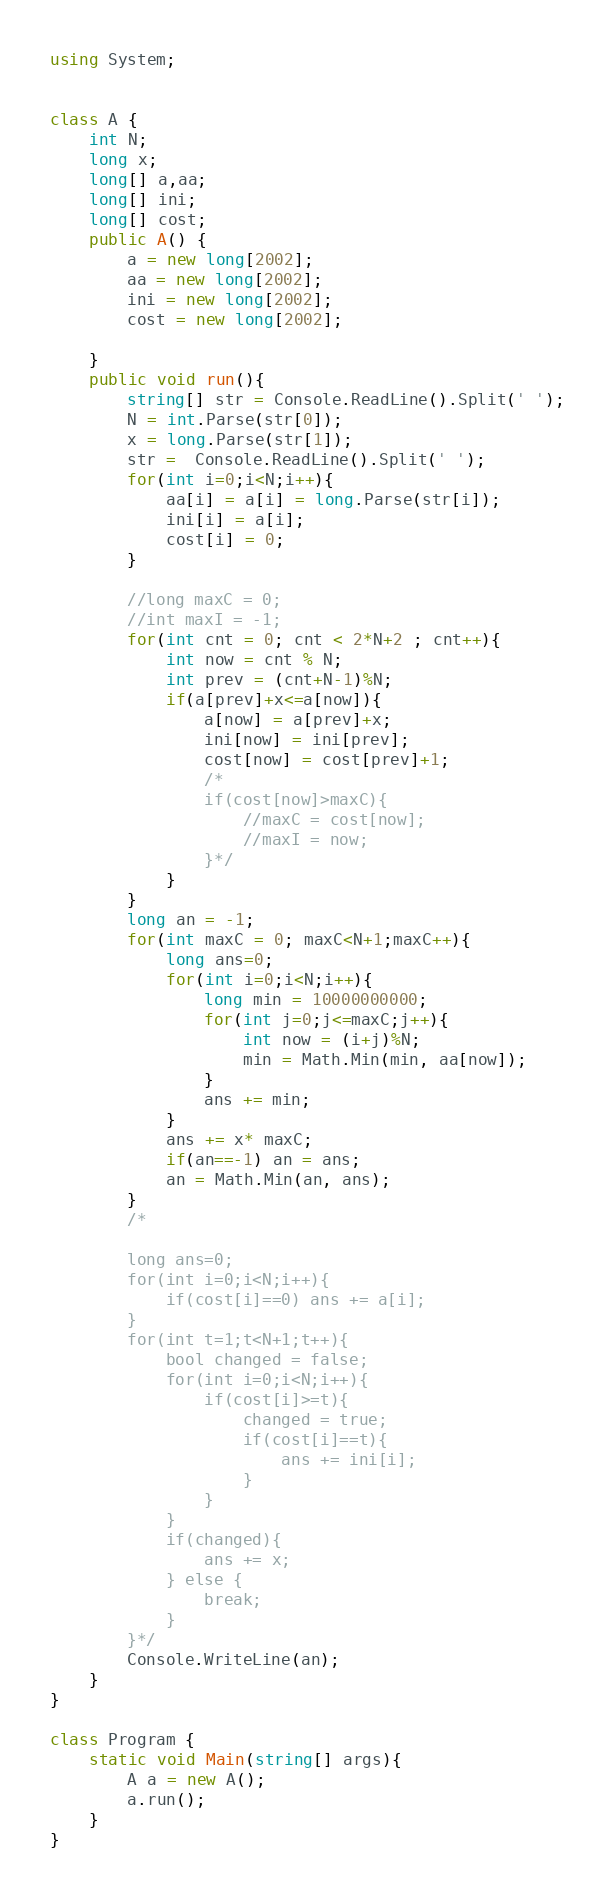Convert code to text. <code><loc_0><loc_0><loc_500><loc_500><_C#_>using System;


class A {
    int N;
    long x;
    long[] a,aa;
    long[] ini;
    long[] cost;
    public A() {
        a = new long[2002];
        aa = new long[2002];
        ini = new long[2002];
        cost = new long[2002];
        
    }
    public void run(){
        string[] str = Console.ReadLine().Split(' ');
        N = int.Parse(str[0]);
        x = long.Parse(str[1]);
        str =  Console.ReadLine().Split(' ');
        for(int i=0;i<N;i++){
            aa[i] = a[i] = long.Parse(str[i]);
            ini[i] = a[i];
            cost[i] = 0;
        }
        
        //long maxC = 0;
        //int maxI = -1;
        for(int cnt = 0; cnt < 2*N+2 ; cnt++){
            int now = cnt % N;
            int prev = (cnt+N-1)%N;
            if(a[prev]+x<=a[now]){
                a[now] = a[prev]+x;
                ini[now] = ini[prev];
                cost[now] = cost[prev]+1; 
                /*
                if(cost[now]>maxC){
                    //maxC = cost[now];
                    //maxI = now;
                }*/
            }
        }
        long an = -1;
        for(int maxC = 0; maxC<N+1;maxC++){
            long ans=0;
            for(int i=0;i<N;i++){
                long min = 10000000000;
                for(int j=0;j<=maxC;j++){
                    int now = (i+j)%N;
                    min = Math.Min(min, aa[now]);
                }
                ans += min;
            }
            ans += x* maxC;
            if(an==-1) an = ans;
            an = Math.Min(an, ans);
        }
        /*
        
        long ans=0;
        for(int i=0;i<N;i++){
            if(cost[i]==0) ans += a[i];
        }
        for(int t=1;t<N+1;t++){
            bool changed = false;
            for(int i=0;i<N;i++){
                if(cost[i]>=t){
                    changed = true;
                    if(cost[i]==t){
                        ans += ini[i];
                    }
                }
            }
            if(changed){
                ans += x;
            } else {
                break;
            }
        }*/
        Console.WriteLine(an);
    }
}

class Program {
    static void Main(string[] args){
        A a = new A();
        a.run();
    }
}</code> 